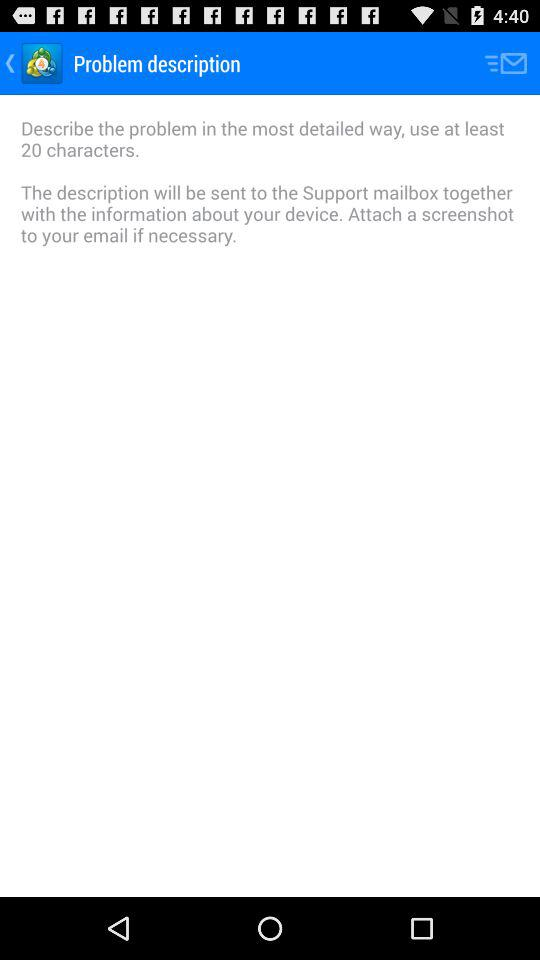What is the user's description of the problem?
When the provided information is insufficient, respond with <no answer>. <no answer> 